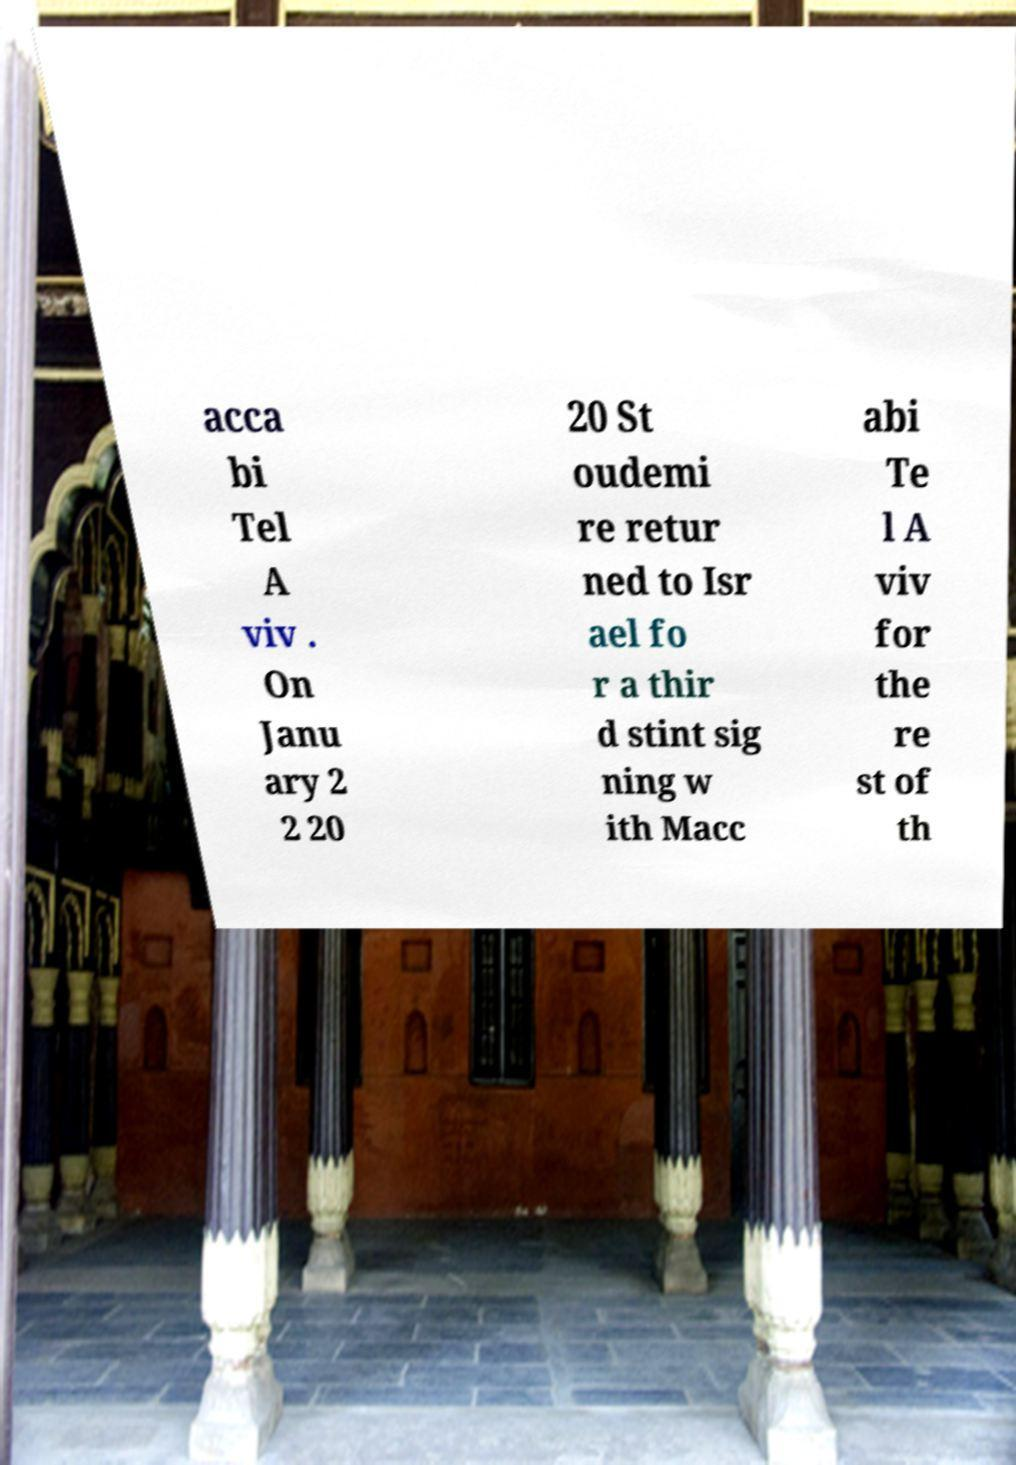Please identify and transcribe the text found in this image. acca bi Tel A viv . On Janu ary 2 2 20 20 St oudemi re retur ned to Isr ael fo r a thir d stint sig ning w ith Macc abi Te l A viv for the re st of th 